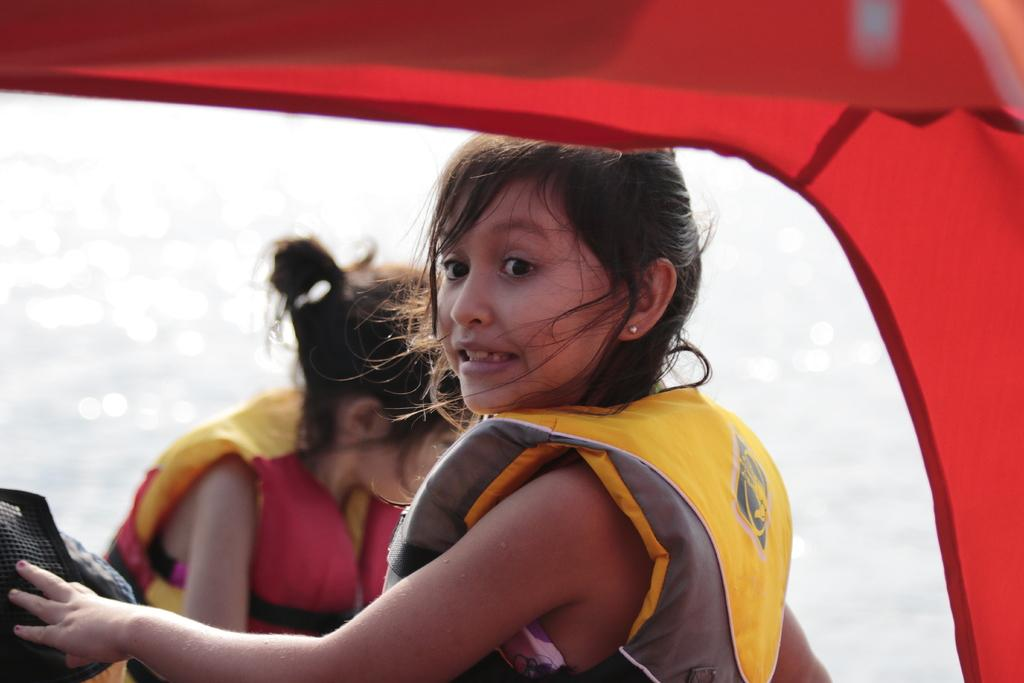What is the main subject of the image? The main subject of the image is a boat. How many people are in the boat? There are two persons in the boat. What are the persons wearing? The persons are wearing jackets. What can be seen around the boat? There is water visible in the image. Where is the light bulb located in the image? There is no light bulb present in the image. What type of furniture can be seen in the boat? There is no furniture, such as a chair, present in the image. 